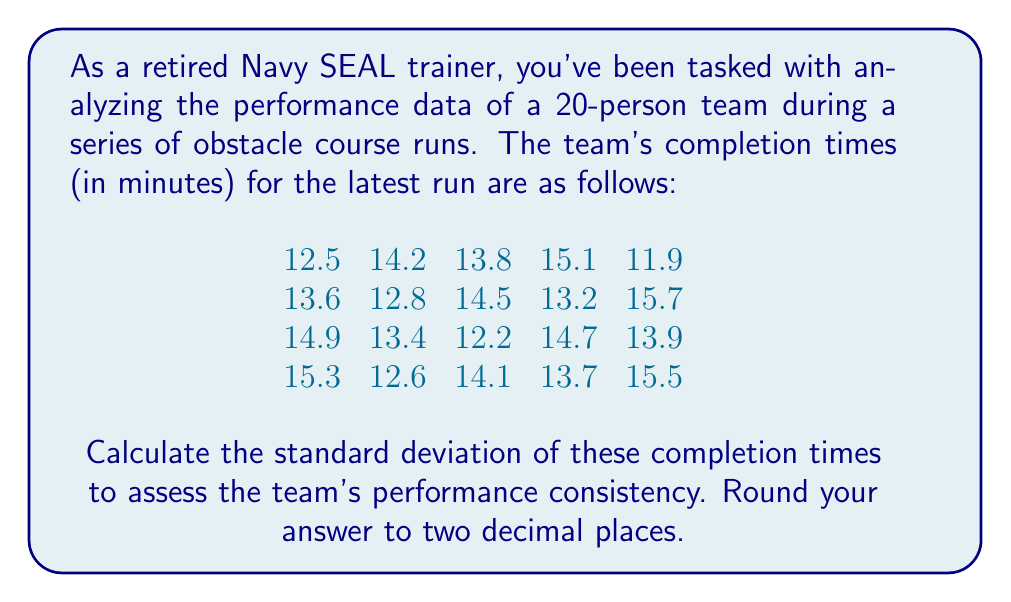Can you answer this question? To calculate the standard deviation, we'll follow these steps:

1) First, calculate the mean ($\mu$) of the completion times:

   $\mu = \frac{\sum_{i=1}^{n} x_i}{n}$

   where $x_i$ are the individual times and $n = 20$.

   $\mu = \frac{273.6}{20} = 13.68$ minutes

2) Next, calculate the squared differences from the mean:

   $(x_i - \mu)^2$ for each time

3) Sum these squared differences:

   $\sum_{i=1}^{n} (x_i - \mu)^2$

4) Divide by $(n-1)$ to get the variance:

   $s^2 = \frac{\sum_{i=1}^{n} (x_i - \mu)^2}{n-1}$

5) Take the square root to get the standard deviation:

   $s = \sqrt{\frac{\sum_{i=1}^{n} (x_i - \mu)^2}{n-1}}$

Calculating the sum of squared differences:

$\sum_{i=1}^{n} (x_i - \mu)^2 = 28.8724$

Now, we can calculate the standard deviation:

$s = \sqrt{\frac{28.8724}{19}} = \sqrt{1.5196} = 1.2327$

Rounding to two decimal places: 1.23
Answer: 1.23 minutes 